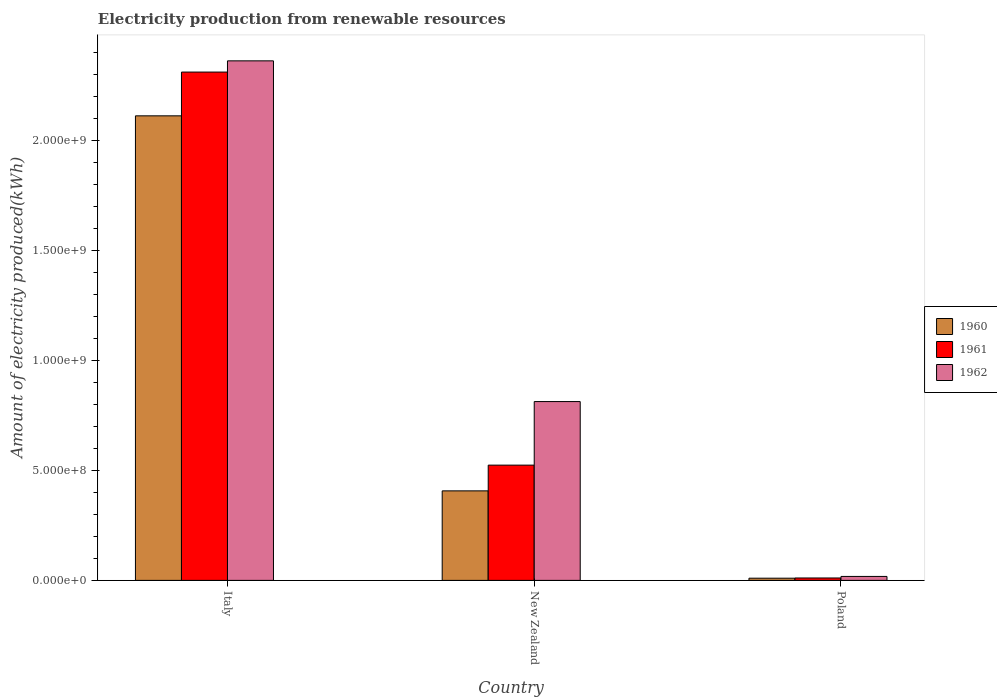Are the number of bars on each tick of the X-axis equal?
Your answer should be compact. Yes. How many bars are there on the 3rd tick from the right?
Offer a terse response. 3. What is the label of the 3rd group of bars from the left?
Make the answer very short. Poland. In how many cases, is the number of bars for a given country not equal to the number of legend labels?
Ensure brevity in your answer.  0. What is the amount of electricity produced in 1962 in Italy?
Provide a succinct answer. 2.36e+09. Across all countries, what is the maximum amount of electricity produced in 1961?
Offer a terse response. 2.31e+09. In which country was the amount of electricity produced in 1962 minimum?
Offer a terse response. Poland. What is the total amount of electricity produced in 1961 in the graph?
Your answer should be compact. 2.85e+09. What is the difference between the amount of electricity produced in 1960 in Italy and that in New Zealand?
Make the answer very short. 1.70e+09. What is the difference between the amount of electricity produced in 1960 in New Zealand and the amount of electricity produced in 1961 in Poland?
Make the answer very short. 3.96e+08. What is the average amount of electricity produced in 1961 per country?
Give a very brief answer. 9.49e+08. What is the difference between the amount of electricity produced of/in 1962 and amount of electricity produced of/in 1960 in New Zealand?
Give a very brief answer. 4.06e+08. What is the ratio of the amount of electricity produced in 1960 in Italy to that in New Zealand?
Your response must be concise. 5.19. Is the difference between the amount of electricity produced in 1962 in New Zealand and Poland greater than the difference between the amount of electricity produced in 1960 in New Zealand and Poland?
Offer a very short reply. Yes. What is the difference between the highest and the second highest amount of electricity produced in 1961?
Give a very brief answer. 1.79e+09. What is the difference between the highest and the lowest amount of electricity produced in 1961?
Your response must be concise. 2.30e+09. In how many countries, is the amount of electricity produced in 1962 greater than the average amount of electricity produced in 1962 taken over all countries?
Give a very brief answer. 1. Is the sum of the amount of electricity produced in 1962 in New Zealand and Poland greater than the maximum amount of electricity produced in 1961 across all countries?
Ensure brevity in your answer.  No. What does the 1st bar from the right in Poland represents?
Provide a short and direct response. 1962. Is it the case that in every country, the sum of the amount of electricity produced in 1960 and amount of electricity produced in 1961 is greater than the amount of electricity produced in 1962?
Offer a terse response. Yes. How many bars are there?
Offer a terse response. 9. Are all the bars in the graph horizontal?
Offer a very short reply. No. How many legend labels are there?
Your response must be concise. 3. What is the title of the graph?
Your answer should be very brief. Electricity production from renewable resources. Does "2012" appear as one of the legend labels in the graph?
Offer a very short reply. No. What is the label or title of the Y-axis?
Ensure brevity in your answer.  Amount of electricity produced(kWh). What is the Amount of electricity produced(kWh) in 1960 in Italy?
Your answer should be compact. 2.11e+09. What is the Amount of electricity produced(kWh) of 1961 in Italy?
Give a very brief answer. 2.31e+09. What is the Amount of electricity produced(kWh) of 1962 in Italy?
Provide a short and direct response. 2.36e+09. What is the Amount of electricity produced(kWh) in 1960 in New Zealand?
Provide a succinct answer. 4.07e+08. What is the Amount of electricity produced(kWh) in 1961 in New Zealand?
Your response must be concise. 5.24e+08. What is the Amount of electricity produced(kWh) in 1962 in New Zealand?
Ensure brevity in your answer.  8.13e+08. What is the Amount of electricity produced(kWh) in 1961 in Poland?
Offer a terse response. 1.10e+07. What is the Amount of electricity produced(kWh) in 1962 in Poland?
Your answer should be compact. 1.80e+07. Across all countries, what is the maximum Amount of electricity produced(kWh) in 1960?
Provide a short and direct response. 2.11e+09. Across all countries, what is the maximum Amount of electricity produced(kWh) of 1961?
Offer a very short reply. 2.31e+09. Across all countries, what is the maximum Amount of electricity produced(kWh) of 1962?
Your answer should be very brief. 2.36e+09. Across all countries, what is the minimum Amount of electricity produced(kWh) in 1961?
Offer a very short reply. 1.10e+07. Across all countries, what is the minimum Amount of electricity produced(kWh) in 1962?
Give a very brief answer. 1.80e+07. What is the total Amount of electricity produced(kWh) in 1960 in the graph?
Offer a very short reply. 2.53e+09. What is the total Amount of electricity produced(kWh) in 1961 in the graph?
Ensure brevity in your answer.  2.85e+09. What is the total Amount of electricity produced(kWh) in 1962 in the graph?
Make the answer very short. 3.19e+09. What is the difference between the Amount of electricity produced(kWh) of 1960 in Italy and that in New Zealand?
Give a very brief answer. 1.70e+09. What is the difference between the Amount of electricity produced(kWh) in 1961 in Italy and that in New Zealand?
Your answer should be very brief. 1.79e+09. What is the difference between the Amount of electricity produced(kWh) in 1962 in Italy and that in New Zealand?
Your answer should be compact. 1.55e+09. What is the difference between the Amount of electricity produced(kWh) of 1960 in Italy and that in Poland?
Make the answer very short. 2.10e+09. What is the difference between the Amount of electricity produced(kWh) in 1961 in Italy and that in Poland?
Provide a succinct answer. 2.30e+09. What is the difference between the Amount of electricity produced(kWh) in 1962 in Italy and that in Poland?
Provide a succinct answer. 2.34e+09. What is the difference between the Amount of electricity produced(kWh) in 1960 in New Zealand and that in Poland?
Offer a very short reply. 3.97e+08. What is the difference between the Amount of electricity produced(kWh) in 1961 in New Zealand and that in Poland?
Your answer should be very brief. 5.13e+08. What is the difference between the Amount of electricity produced(kWh) of 1962 in New Zealand and that in Poland?
Give a very brief answer. 7.95e+08. What is the difference between the Amount of electricity produced(kWh) of 1960 in Italy and the Amount of electricity produced(kWh) of 1961 in New Zealand?
Provide a succinct answer. 1.59e+09. What is the difference between the Amount of electricity produced(kWh) of 1960 in Italy and the Amount of electricity produced(kWh) of 1962 in New Zealand?
Your answer should be compact. 1.30e+09. What is the difference between the Amount of electricity produced(kWh) in 1961 in Italy and the Amount of electricity produced(kWh) in 1962 in New Zealand?
Make the answer very short. 1.50e+09. What is the difference between the Amount of electricity produced(kWh) in 1960 in Italy and the Amount of electricity produced(kWh) in 1961 in Poland?
Offer a terse response. 2.10e+09. What is the difference between the Amount of electricity produced(kWh) of 1960 in Italy and the Amount of electricity produced(kWh) of 1962 in Poland?
Offer a very short reply. 2.09e+09. What is the difference between the Amount of electricity produced(kWh) of 1961 in Italy and the Amount of electricity produced(kWh) of 1962 in Poland?
Provide a succinct answer. 2.29e+09. What is the difference between the Amount of electricity produced(kWh) in 1960 in New Zealand and the Amount of electricity produced(kWh) in 1961 in Poland?
Provide a succinct answer. 3.96e+08. What is the difference between the Amount of electricity produced(kWh) of 1960 in New Zealand and the Amount of electricity produced(kWh) of 1962 in Poland?
Make the answer very short. 3.89e+08. What is the difference between the Amount of electricity produced(kWh) in 1961 in New Zealand and the Amount of electricity produced(kWh) in 1962 in Poland?
Ensure brevity in your answer.  5.06e+08. What is the average Amount of electricity produced(kWh) in 1960 per country?
Offer a very short reply. 8.43e+08. What is the average Amount of electricity produced(kWh) of 1961 per country?
Make the answer very short. 9.49e+08. What is the average Amount of electricity produced(kWh) in 1962 per country?
Provide a succinct answer. 1.06e+09. What is the difference between the Amount of electricity produced(kWh) in 1960 and Amount of electricity produced(kWh) in 1961 in Italy?
Keep it short and to the point. -1.99e+08. What is the difference between the Amount of electricity produced(kWh) of 1960 and Amount of electricity produced(kWh) of 1962 in Italy?
Provide a short and direct response. -2.50e+08. What is the difference between the Amount of electricity produced(kWh) in 1961 and Amount of electricity produced(kWh) in 1962 in Italy?
Give a very brief answer. -5.10e+07. What is the difference between the Amount of electricity produced(kWh) in 1960 and Amount of electricity produced(kWh) in 1961 in New Zealand?
Offer a very short reply. -1.17e+08. What is the difference between the Amount of electricity produced(kWh) of 1960 and Amount of electricity produced(kWh) of 1962 in New Zealand?
Offer a very short reply. -4.06e+08. What is the difference between the Amount of electricity produced(kWh) in 1961 and Amount of electricity produced(kWh) in 1962 in New Zealand?
Keep it short and to the point. -2.89e+08. What is the difference between the Amount of electricity produced(kWh) of 1960 and Amount of electricity produced(kWh) of 1961 in Poland?
Your answer should be compact. -1.00e+06. What is the difference between the Amount of electricity produced(kWh) in 1960 and Amount of electricity produced(kWh) in 1962 in Poland?
Offer a terse response. -8.00e+06. What is the difference between the Amount of electricity produced(kWh) in 1961 and Amount of electricity produced(kWh) in 1962 in Poland?
Offer a terse response. -7.00e+06. What is the ratio of the Amount of electricity produced(kWh) in 1960 in Italy to that in New Zealand?
Provide a short and direct response. 5.19. What is the ratio of the Amount of electricity produced(kWh) of 1961 in Italy to that in New Zealand?
Give a very brief answer. 4.41. What is the ratio of the Amount of electricity produced(kWh) of 1962 in Italy to that in New Zealand?
Your answer should be very brief. 2.91. What is the ratio of the Amount of electricity produced(kWh) in 1960 in Italy to that in Poland?
Your response must be concise. 211.2. What is the ratio of the Amount of electricity produced(kWh) of 1961 in Italy to that in Poland?
Keep it short and to the point. 210.09. What is the ratio of the Amount of electricity produced(kWh) of 1962 in Italy to that in Poland?
Offer a terse response. 131.22. What is the ratio of the Amount of electricity produced(kWh) in 1960 in New Zealand to that in Poland?
Keep it short and to the point. 40.7. What is the ratio of the Amount of electricity produced(kWh) in 1961 in New Zealand to that in Poland?
Your answer should be compact. 47.64. What is the ratio of the Amount of electricity produced(kWh) in 1962 in New Zealand to that in Poland?
Give a very brief answer. 45.17. What is the difference between the highest and the second highest Amount of electricity produced(kWh) in 1960?
Give a very brief answer. 1.70e+09. What is the difference between the highest and the second highest Amount of electricity produced(kWh) in 1961?
Ensure brevity in your answer.  1.79e+09. What is the difference between the highest and the second highest Amount of electricity produced(kWh) of 1962?
Offer a very short reply. 1.55e+09. What is the difference between the highest and the lowest Amount of electricity produced(kWh) of 1960?
Offer a very short reply. 2.10e+09. What is the difference between the highest and the lowest Amount of electricity produced(kWh) of 1961?
Your response must be concise. 2.30e+09. What is the difference between the highest and the lowest Amount of electricity produced(kWh) of 1962?
Your answer should be very brief. 2.34e+09. 